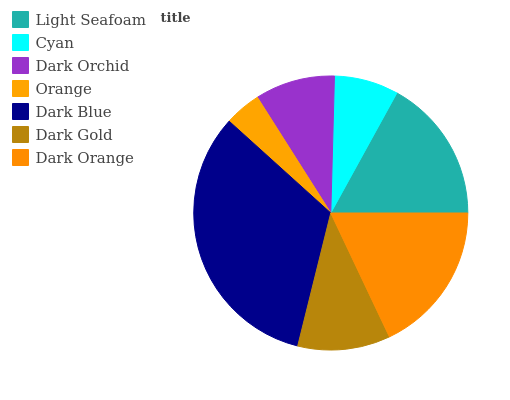Is Orange the minimum?
Answer yes or no. Yes. Is Dark Blue the maximum?
Answer yes or no. Yes. Is Cyan the minimum?
Answer yes or no. No. Is Cyan the maximum?
Answer yes or no. No. Is Light Seafoam greater than Cyan?
Answer yes or no. Yes. Is Cyan less than Light Seafoam?
Answer yes or no. Yes. Is Cyan greater than Light Seafoam?
Answer yes or no. No. Is Light Seafoam less than Cyan?
Answer yes or no. No. Is Dark Gold the high median?
Answer yes or no. Yes. Is Dark Gold the low median?
Answer yes or no. Yes. Is Dark Blue the high median?
Answer yes or no. No. Is Dark Orange the low median?
Answer yes or no. No. 